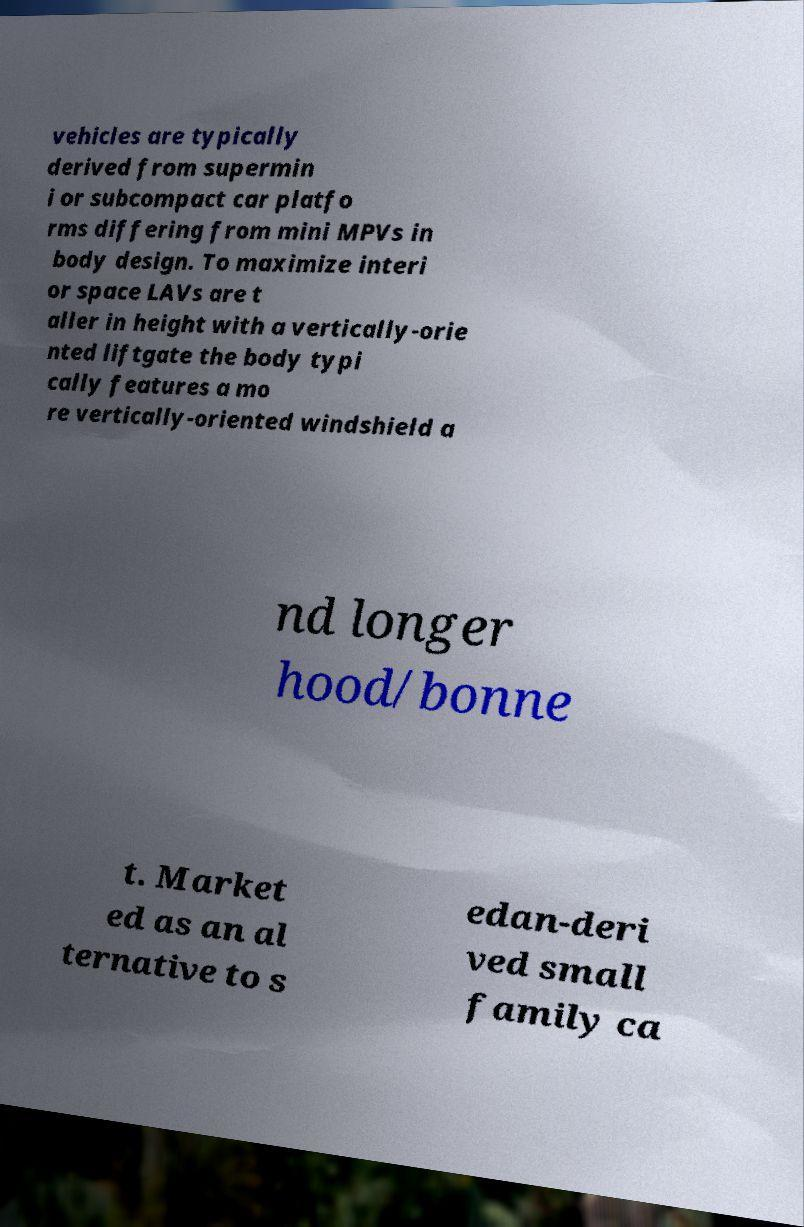What messages or text are displayed in this image? I need them in a readable, typed format. vehicles are typically derived from supermin i or subcompact car platfo rms differing from mini MPVs in body design. To maximize interi or space LAVs are t aller in height with a vertically-orie nted liftgate the body typi cally features a mo re vertically-oriented windshield a nd longer hood/bonne t. Market ed as an al ternative to s edan-deri ved small family ca 